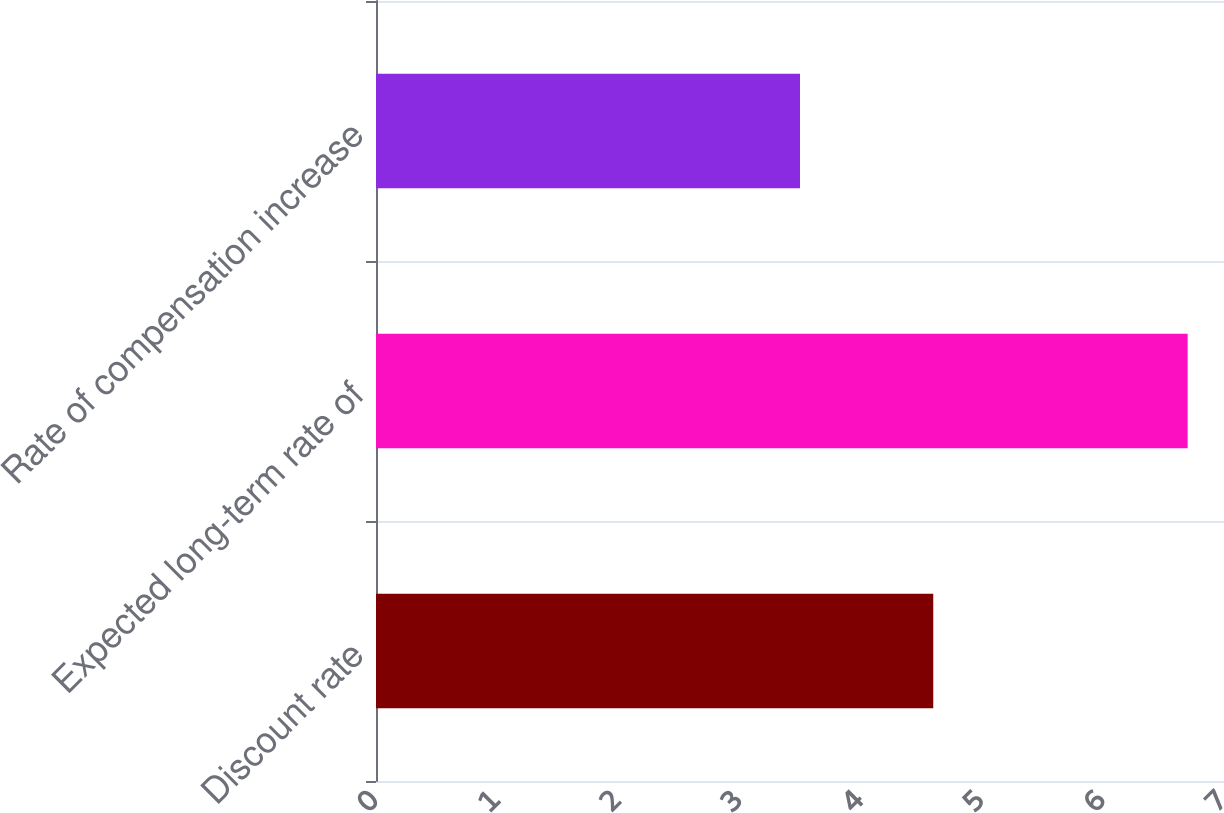Convert chart. <chart><loc_0><loc_0><loc_500><loc_500><bar_chart><fcel>Discount rate<fcel>Expected long-term rate of<fcel>Rate of compensation increase<nl><fcel>4.6<fcel>6.7<fcel>3.5<nl></chart> 